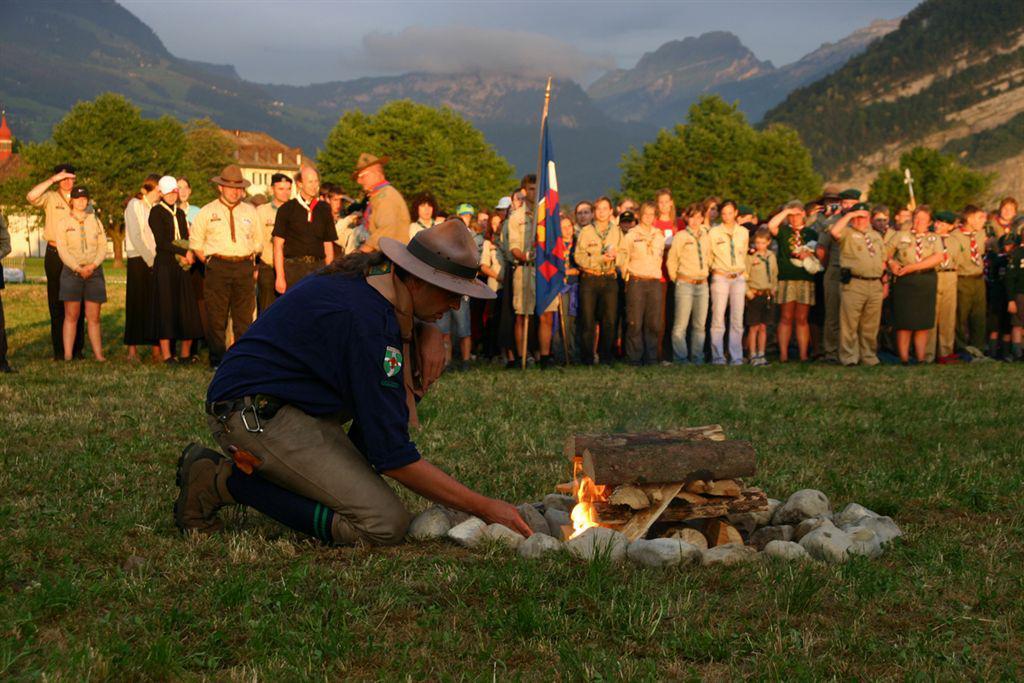Describe this image in one or two sentences. In this image we can see few people standing on the ground, a person is holding flags and a person is lightning the fire to the wooden sticks and there are stones around the sticks, there are few trees, a building and the sky in the background. 